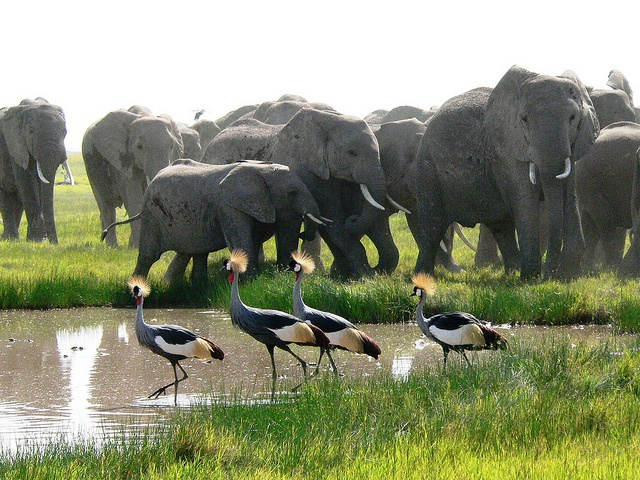Describe the objects in this image and their specific colors. I can see elephant in white, gray, black, and darkgreen tones, elephant in white, black, gray, and darkgreen tones, elephant in white, gray, black, darkgray, and lightgray tones, elephant in white, black, gray, and darkgreen tones, and elephant in white, gray, black, darkgreen, and darkgray tones in this image. 